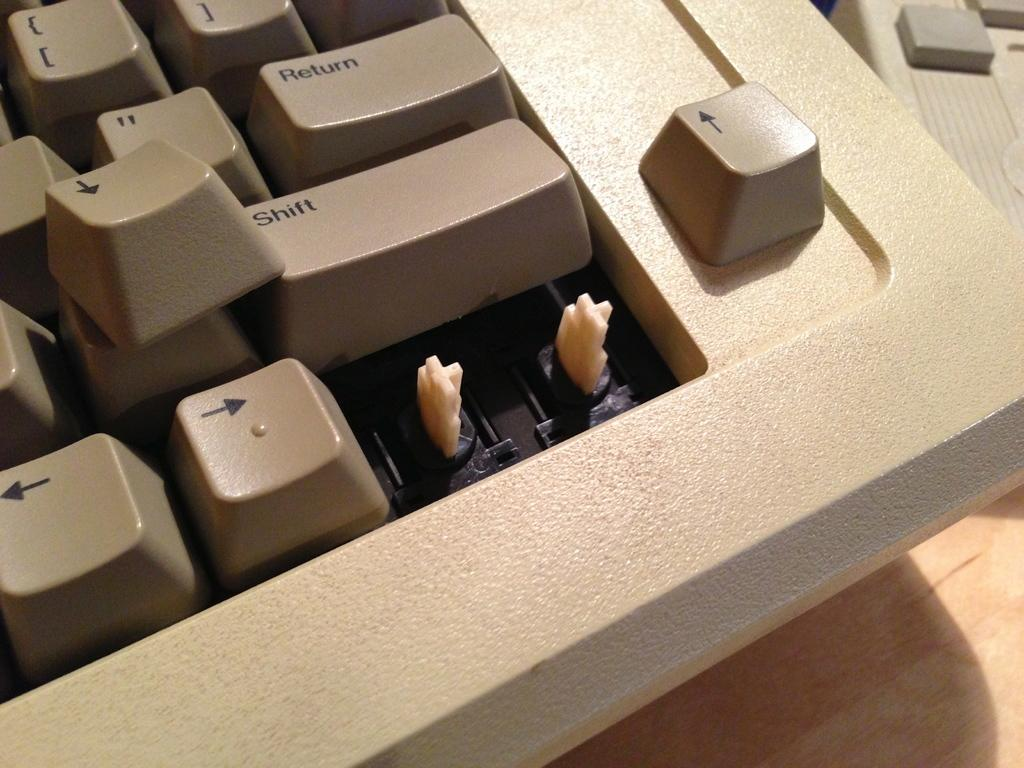<image>
Give a short and clear explanation of the subsequent image. Keyboard with a button that says Return above another one that says SHIFT. 